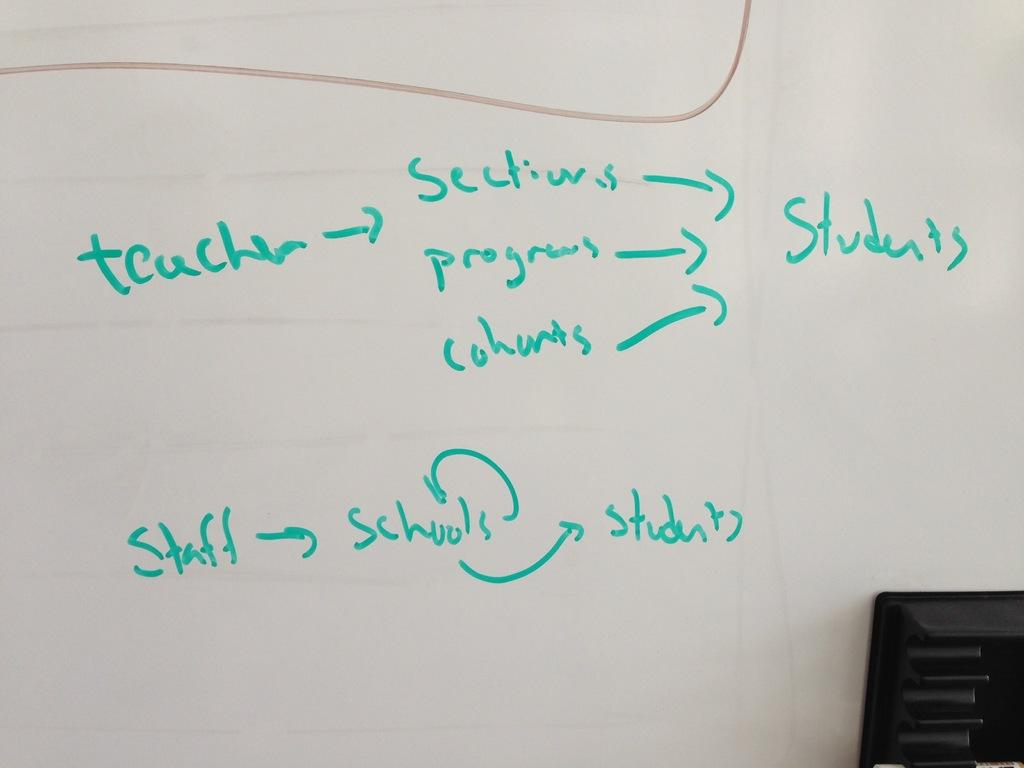<image>
Offer a succinct explanation of the picture presented. a write on wipe off board has a display of what teachers give to students 